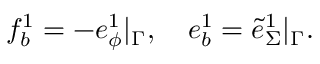<formula> <loc_0><loc_0><loc_500><loc_500>f _ { b } ^ { 1 } = - e _ { \phi } ^ { 1 } | _ { \Gamma } , \quad e _ { b } ^ { 1 } = \tilde { e } _ { \Sigma } ^ { 1 } | _ { \Gamma } .</formula> 